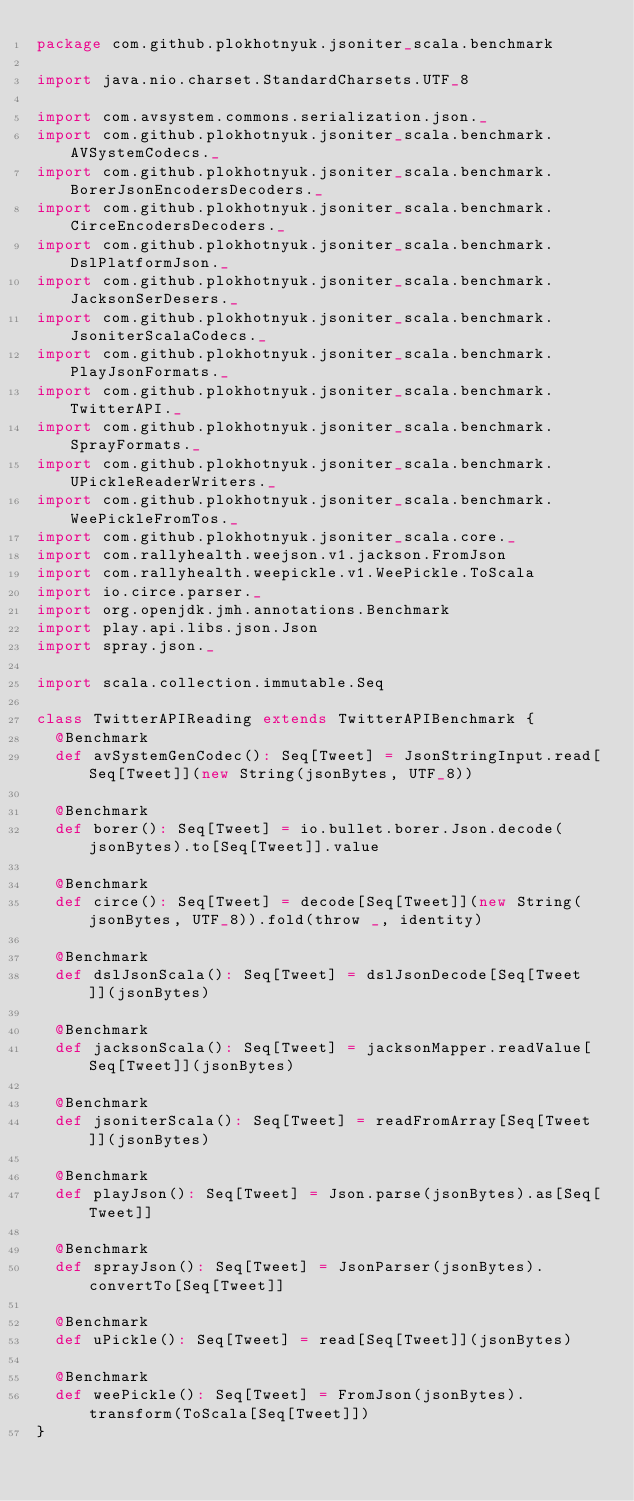<code> <loc_0><loc_0><loc_500><loc_500><_Scala_>package com.github.plokhotnyuk.jsoniter_scala.benchmark

import java.nio.charset.StandardCharsets.UTF_8

import com.avsystem.commons.serialization.json._
import com.github.plokhotnyuk.jsoniter_scala.benchmark.AVSystemCodecs._
import com.github.plokhotnyuk.jsoniter_scala.benchmark.BorerJsonEncodersDecoders._
import com.github.plokhotnyuk.jsoniter_scala.benchmark.CirceEncodersDecoders._
import com.github.plokhotnyuk.jsoniter_scala.benchmark.DslPlatformJson._
import com.github.plokhotnyuk.jsoniter_scala.benchmark.JacksonSerDesers._
import com.github.plokhotnyuk.jsoniter_scala.benchmark.JsoniterScalaCodecs._
import com.github.plokhotnyuk.jsoniter_scala.benchmark.PlayJsonFormats._
import com.github.plokhotnyuk.jsoniter_scala.benchmark.TwitterAPI._
import com.github.plokhotnyuk.jsoniter_scala.benchmark.SprayFormats._
import com.github.plokhotnyuk.jsoniter_scala.benchmark.UPickleReaderWriters._
import com.github.plokhotnyuk.jsoniter_scala.benchmark.WeePickleFromTos._
import com.github.plokhotnyuk.jsoniter_scala.core._
import com.rallyhealth.weejson.v1.jackson.FromJson
import com.rallyhealth.weepickle.v1.WeePickle.ToScala
import io.circe.parser._
import org.openjdk.jmh.annotations.Benchmark
import play.api.libs.json.Json
import spray.json._

import scala.collection.immutable.Seq

class TwitterAPIReading extends TwitterAPIBenchmark {
  @Benchmark
  def avSystemGenCodec(): Seq[Tweet] = JsonStringInput.read[Seq[Tweet]](new String(jsonBytes, UTF_8))

  @Benchmark
  def borer(): Seq[Tweet] = io.bullet.borer.Json.decode(jsonBytes).to[Seq[Tweet]].value

  @Benchmark
  def circe(): Seq[Tweet] = decode[Seq[Tweet]](new String(jsonBytes, UTF_8)).fold(throw _, identity)

  @Benchmark
  def dslJsonScala(): Seq[Tweet] = dslJsonDecode[Seq[Tweet]](jsonBytes)

  @Benchmark
  def jacksonScala(): Seq[Tweet] = jacksonMapper.readValue[Seq[Tweet]](jsonBytes)

  @Benchmark
  def jsoniterScala(): Seq[Tweet] = readFromArray[Seq[Tweet]](jsonBytes)

  @Benchmark
  def playJson(): Seq[Tweet] = Json.parse(jsonBytes).as[Seq[Tweet]]

  @Benchmark
  def sprayJson(): Seq[Tweet] = JsonParser(jsonBytes).convertTo[Seq[Tweet]]

  @Benchmark
  def uPickle(): Seq[Tweet] = read[Seq[Tweet]](jsonBytes)

  @Benchmark
  def weePickle(): Seq[Tweet] = FromJson(jsonBytes).transform(ToScala[Seq[Tweet]])
}</code> 